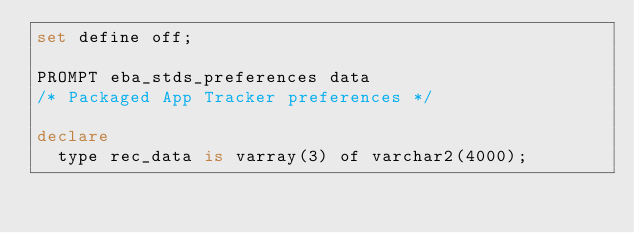<code> <loc_0><loc_0><loc_500><loc_500><_SQL_>set define off;

PROMPT eba_stds_preferences data
/* Packaged App Tracker preferences */

declare
  type rec_data is varray(3) of varchar2(4000);</code> 